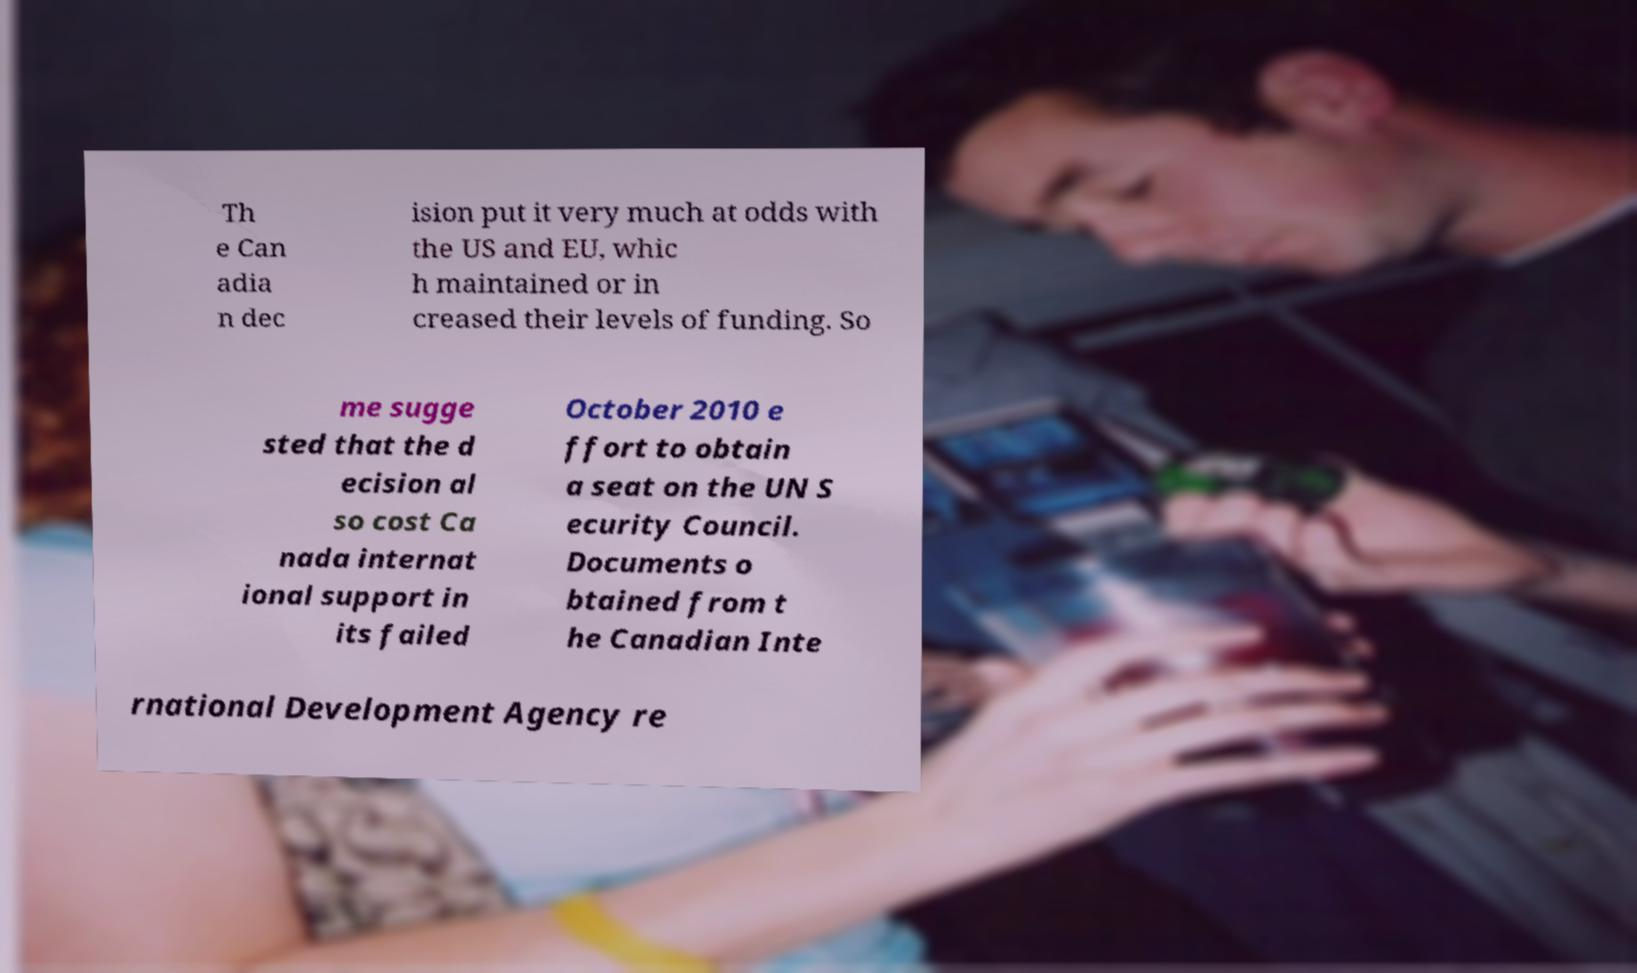Could you extract and type out the text from this image? Th e Can adia n dec ision put it very much at odds with the US and EU, whic h maintained or in creased their levels of funding. So me sugge sted that the d ecision al so cost Ca nada internat ional support in its failed October 2010 e ffort to obtain a seat on the UN S ecurity Council. Documents o btained from t he Canadian Inte rnational Development Agency re 